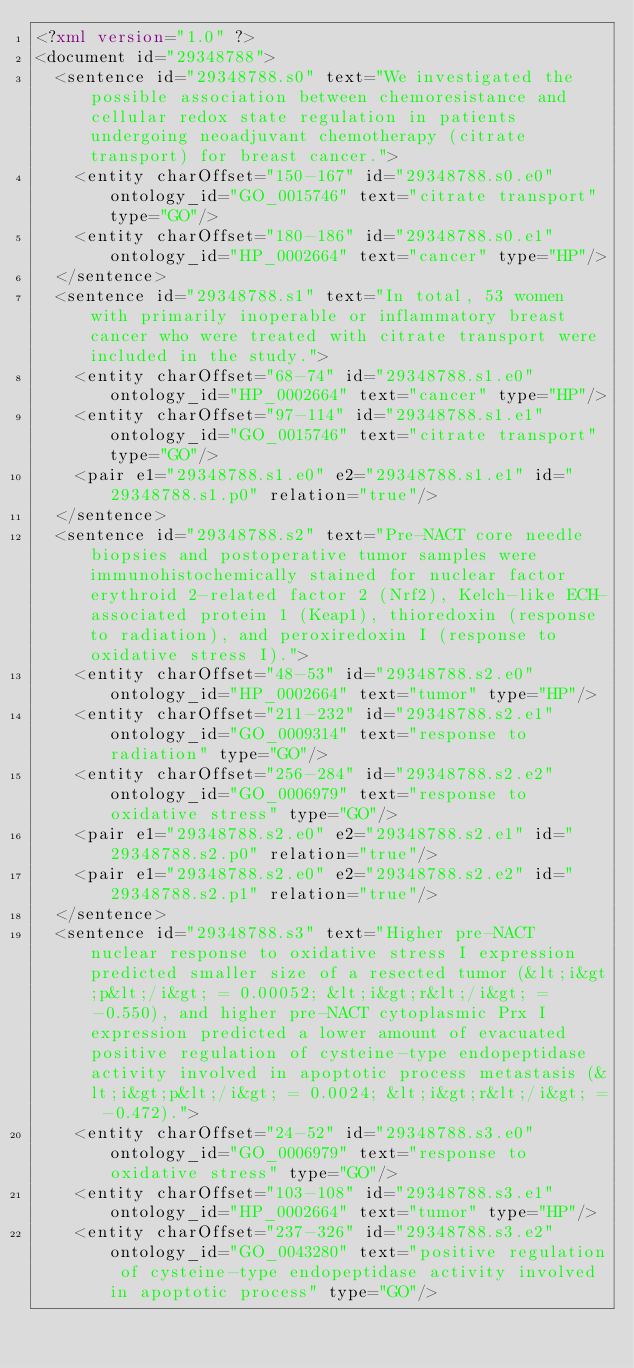<code> <loc_0><loc_0><loc_500><loc_500><_XML_><?xml version="1.0" ?>
<document id="29348788">
  <sentence id="29348788.s0" text="We investigated the possible association between chemoresistance and cellular redox state regulation in patients undergoing neoadjuvant chemotherapy (citrate transport) for breast cancer.">
    <entity charOffset="150-167" id="29348788.s0.e0" ontology_id="GO_0015746" text="citrate transport" type="GO"/>
    <entity charOffset="180-186" id="29348788.s0.e1" ontology_id="HP_0002664" text="cancer" type="HP"/>
  </sentence>
  <sentence id="29348788.s1" text="In total, 53 women with primarily inoperable or inflammatory breast cancer who were treated with citrate transport were included in the study.">
    <entity charOffset="68-74" id="29348788.s1.e0" ontology_id="HP_0002664" text="cancer" type="HP"/>
    <entity charOffset="97-114" id="29348788.s1.e1" ontology_id="GO_0015746" text="citrate transport" type="GO"/>
    <pair e1="29348788.s1.e0" e2="29348788.s1.e1" id="29348788.s1.p0" relation="true"/>
  </sentence>
  <sentence id="29348788.s2" text="Pre-NACT core needle biopsies and postoperative tumor samples were immunohistochemically stained for nuclear factor erythroid 2-related factor 2 (Nrf2), Kelch-like ECH-associated protein 1 (Keap1), thioredoxin (response to radiation), and peroxiredoxin I (response to oxidative stress I).">
    <entity charOffset="48-53" id="29348788.s2.e0" ontology_id="HP_0002664" text="tumor" type="HP"/>
    <entity charOffset="211-232" id="29348788.s2.e1" ontology_id="GO_0009314" text="response to radiation" type="GO"/>
    <entity charOffset="256-284" id="29348788.s2.e2" ontology_id="GO_0006979" text="response to oxidative stress" type="GO"/>
    <pair e1="29348788.s2.e0" e2="29348788.s2.e1" id="29348788.s2.p0" relation="true"/>
    <pair e1="29348788.s2.e0" e2="29348788.s2.e2" id="29348788.s2.p1" relation="true"/>
  </sentence>
  <sentence id="29348788.s3" text="Higher pre-NACT nuclear response to oxidative stress I expression predicted smaller size of a resected tumor (&lt;i&gt;p&lt;/i&gt; = 0.00052; &lt;i&gt;r&lt;/i&gt; = -0.550), and higher pre-NACT cytoplasmic Prx I expression predicted a lower amount of evacuated positive regulation of cysteine-type endopeptidase activity involved in apoptotic process metastasis (&lt;i&gt;p&lt;/i&gt; = 0.0024; &lt;i&gt;r&lt;/i&gt; = -0.472).">
    <entity charOffset="24-52" id="29348788.s3.e0" ontology_id="GO_0006979" text="response to oxidative stress" type="GO"/>
    <entity charOffset="103-108" id="29348788.s3.e1" ontology_id="HP_0002664" text="tumor" type="HP"/>
    <entity charOffset="237-326" id="29348788.s3.e2" ontology_id="GO_0043280" text="positive regulation of cysteine-type endopeptidase activity involved in apoptotic process" type="GO"/></code> 